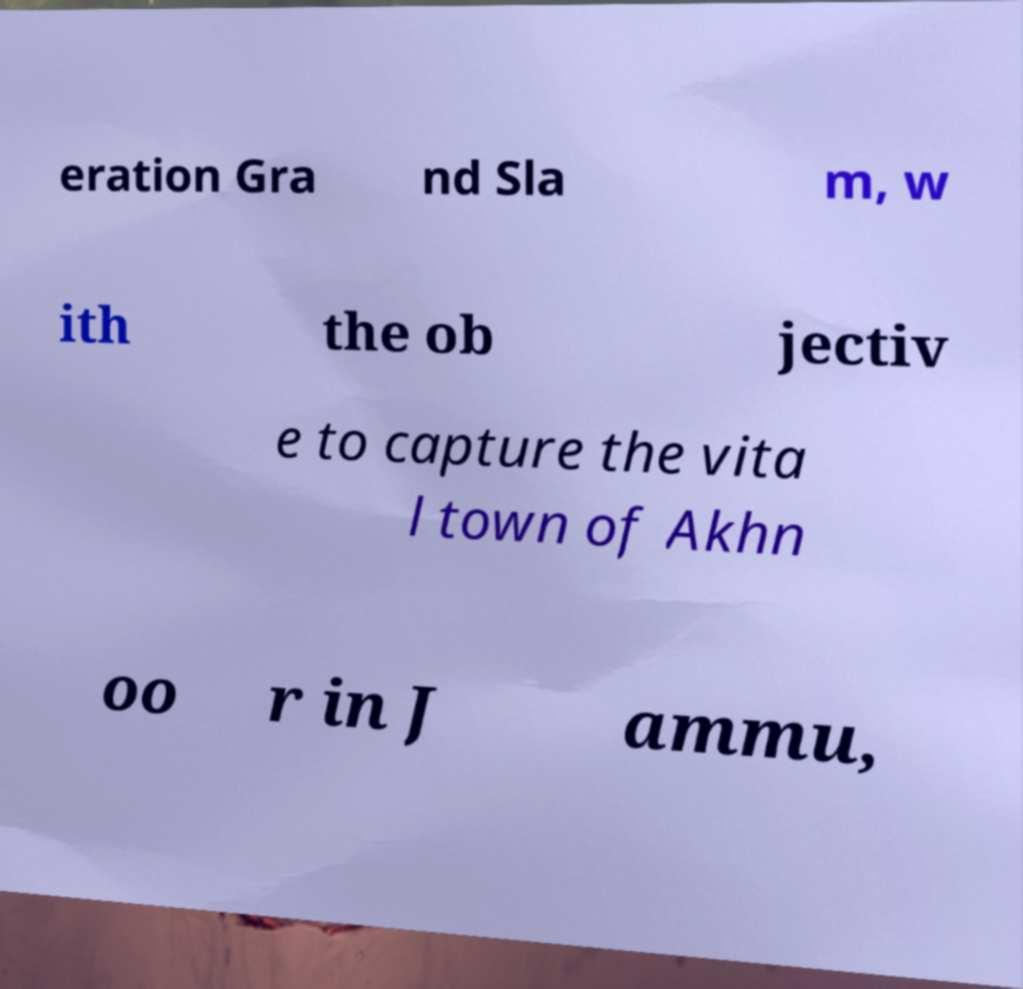I need the written content from this picture converted into text. Can you do that? eration Gra nd Sla m, w ith the ob jectiv e to capture the vita l town of Akhn oo r in J ammu, 